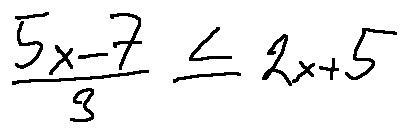Convert formula to latex. <formula><loc_0><loc_0><loc_500><loc_500>\frac { 5 x - 7 } { 3 } \leq 2 x + 5</formula> 